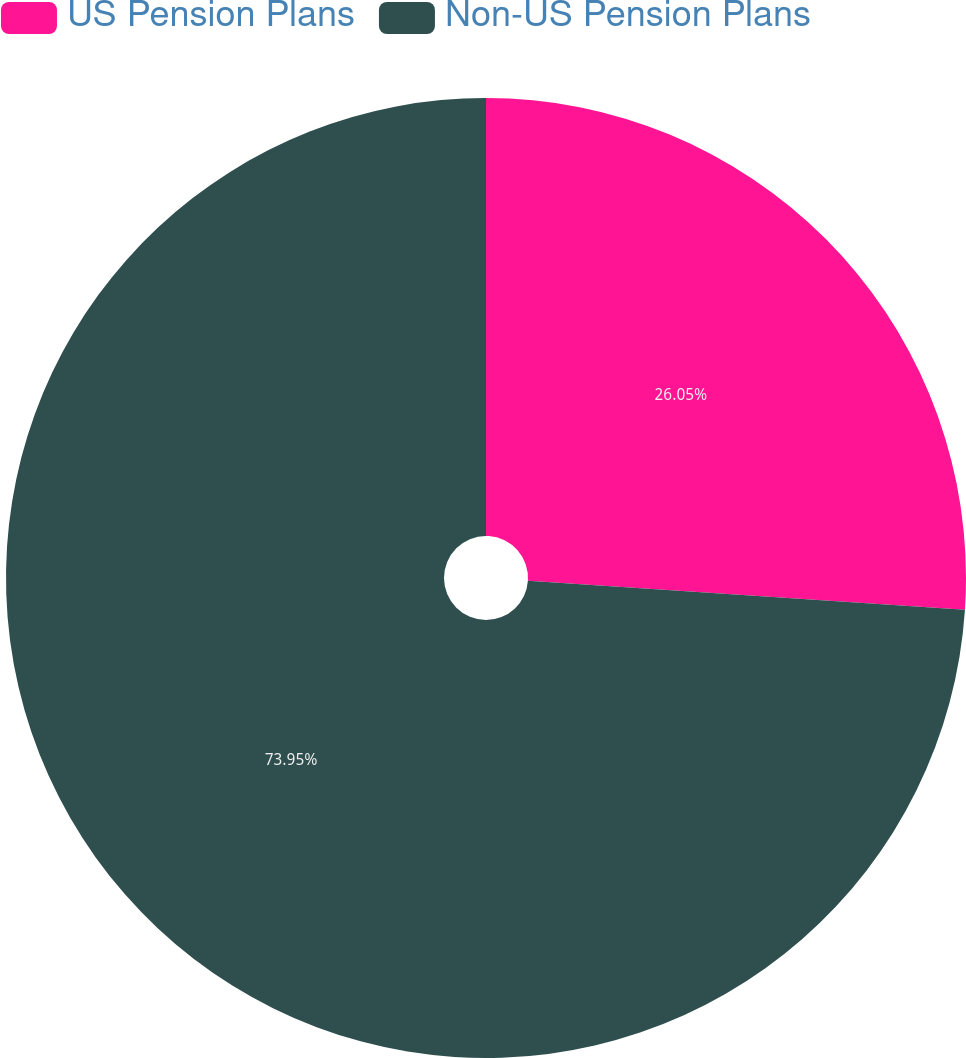Convert chart. <chart><loc_0><loc_0><loc_500><loc_500><pie_chart><fcel>US Pension Plans<fcel>Non-US Pension Plans<nl><fcel>26.05%<fcel>73.95%<nl></chart> 